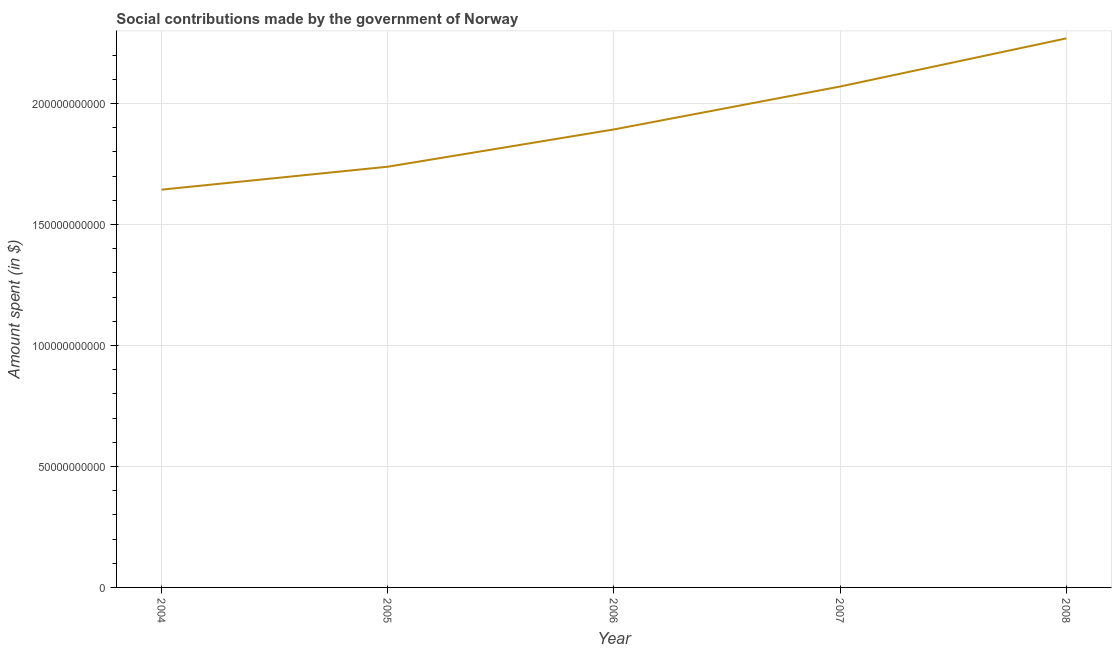What is the amount spent in making social contributions in 2004?
Your answer should be very brief. 1.64e+11. Across all years, what is the maximum amount spent in making social contributions?
Offer a very short reply. 2.27e+11. Across all years, what is the minimum amount spent in making social contributions?
Offer a terse response. 1.64e+11. In which year was the amount spent in making social contributions maximum?
Ensure brevity in your answer.  2008. What is the sum of the amount spent in making social contributions?
Make the answer very short. 9.61e+11. What is the difference between the amount spent in making social contributions in 2006 and 2008?
Make the answer very short. -3.76e+1. What is the average amount spent in making social contributions per year?
Make the answer very short. 1.92e+11. What is the median amount spent in making social contributions?
Ensure brevity in your answer.  1.89e+11. What is the ratio of the amount spent in making social contributions in 2005 to that in 2006?
Keep it short and to the point. 0.92. What is the difference between the highest and the second highest amount spent in making social contributions?
Offer a terse response. 1.99e+1. Is the sum of the amount spent in making social contributions in 2004 and 2008 greater than the maximum amount spent in making social contributions across all years?
Your response must be concise. Yes. What is the difference between the highest and the lowest amount spent in making social contributions?
Offer a terse response. 6.25e+1. Does the amount spent in making social contributions monotonically increase over the years?
Your answer should be compact. Yes. What is the difference between two consecutive major ticks on the Y-axis?
Keep it short and to the point. 5.00e+1. Are the values on the major ticks of Y-axis written in scientific E-notation?
Give a very brief answer. No. What is the title of the graph?
Your answer should be compact. Social contributions made by the government of Norway. What is the label or title of the Y-axis?
Your answer should be very brief. Amount spent (in $). What is the Amount spent (in $) in 2004?
Provide a succinct answer. 1.64e+11. What is the Amount spent (in $) in 2005?
Your answer should be compact. 1.74e+11. What is the Amount spent (in $) of 2006?
Give a very brief answer. 1.89e+11. What is the Amount spent (in $) in 2007?
Keep it short and to the point. 2.07e+11. What is the Amount spent (in $) of 2008?
Offer a very short reply. 2.27e+11. What is the difference between the Amount spent (in $) in 2004 and 2005?
Provide a short and direct response. -9.48e+09. What is the difference between the Amount spent (in $) in 2004 and 2006?
Provide a succinct answer. -2.49e+1. What is the difference between the Amount spent (in $) in 2004 and 2007?
Your answer should be very brief. -4.26e+1. What is the difference between the Amount spent (in $) in 2004 and 2008?
Give a very brief answer. -6.25e+1. What is the difference between the Amount spent (in $) in 2005 and 2006?
Your response must be concise. -1.54e+1. What is the difference between the Amount spent (in $) in 2005 and 2007?
Keep it short and to the point. -3.31e+1. What is the difference between the Amount spent (in $) in 2005 and 2008?
Your response must be concise. -5.30e+1. What is the difference between the Amount spent (in $) in 2006 and 2007?
Ensure brevity in your answer.  -1.77e+1. What is the difference between the Amount spent (in $) in 2006 and 2008?
Make the answer very short. -3.76e+1. What is the difference between the Amount spent (in $) in 2007 and 2008?
Offer a terse response. -1.99e+1. What is the ratio of the Amount spent (in $) in 2004 to that in 2005?
Offer a terse response. 0.94. What is the ratio of the Amount spent (in $) in 2004 to that in 2006?
Provide a succinct answer. 0.87. What is the ratio of the Amount spent (in $) in 2004 to that in 2007?
Your answer should be very brief. 0.79. What is the ratio of the Amount spent (in $) in 2004 to that in 2008?
Provide a short and direct response. 0.72. What is the ratio of the Amount spent (in $) in 2005 to that in 2006?
Make the answer very short. 0.92. What is the ratio of the Amount spent (in $) in 2005 to that in 2007?
Offer a very short reply. 0.84. What is the ratio of the Amount spent (in $) in 2005 to that in 2008?
Offer a very short reply. 0.77. What is the ratio of the Amount spent (in $) in 2006 to that in 2007?
Ensure brevity in your answer.  0.91. What is the ratio of the Amount spent (in $) in 2006 to that in 2008?
Provide a succinct answer. 0.83. What is the ratio of the Amount spent (in $) in 2007 to that in 2008?
Your response must be concise. 0.91. 